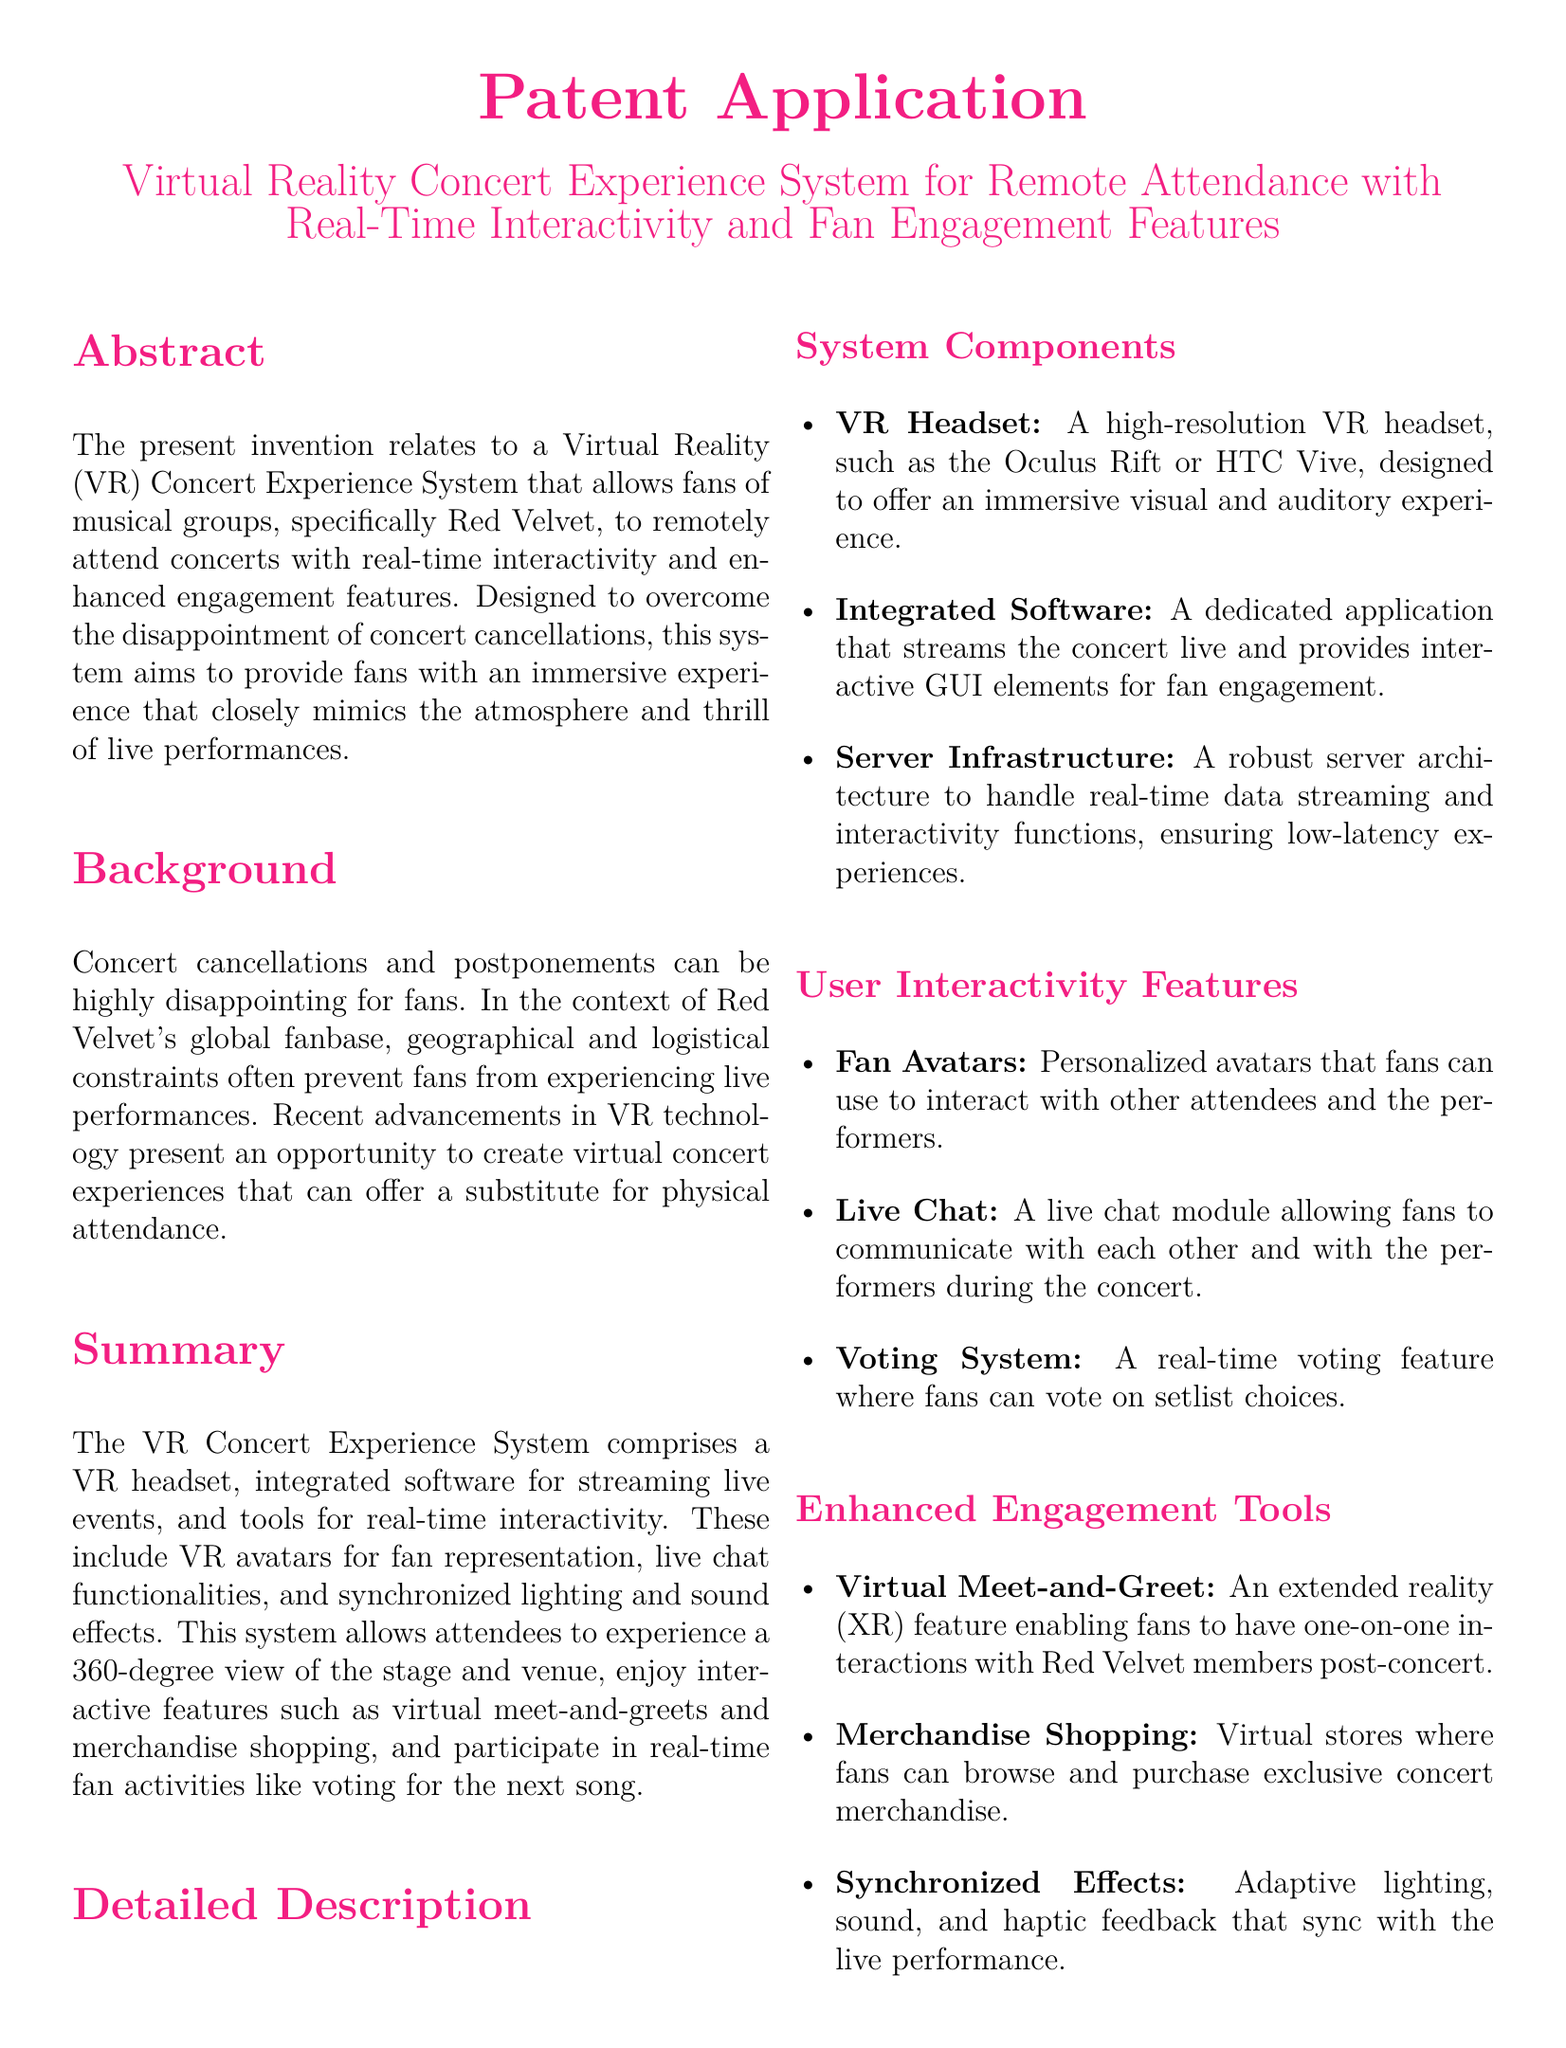what is the title of the patent application? The title is specified in the document header, indicating the subject of the invention.
Answer: Virtual Reality Concert Experience System for Remote Attendance with Real-Time Interactivity and Fan Engagement Features who is the target audience of the VR Concert Experience System? The document mentions that this system is designed specifically for fans of musical groups, notably Red Velvet.
Answer: fans of musical groups, specifically Red Velvet what is one key feature of the user interactivity tools? The document lists various features under user interactivity that enhance fan participation during concerts.
Answer: personalized avatars how does the system enhance fan engagement? The document describes several tools that aim to create a more interactive and engaging experience for fans during concerts.
Answer: virtual meet-and-greet how many claims are made in the patent? The document enumerates the claims under the "Claims" section, indicating the number of claims made.
Answer: three what technology is integrated for streaming events? The document specifies the technology used for live streaming of concerts as part of the VR system.
Answer: integrated software which VR headset examples are mentioned? The document lists specific headset models to illustrate the technology required to experience the VR concerts.
Answer: Oculus Rift or HTC Vive what does the conclusion suggest about the VR Concert Experience System? The conclusion summarizes the benefits and expectations from the system based on the features described throughout the document.
Answer: transforms how Red Velvet fans can enjoy concerts remotely 